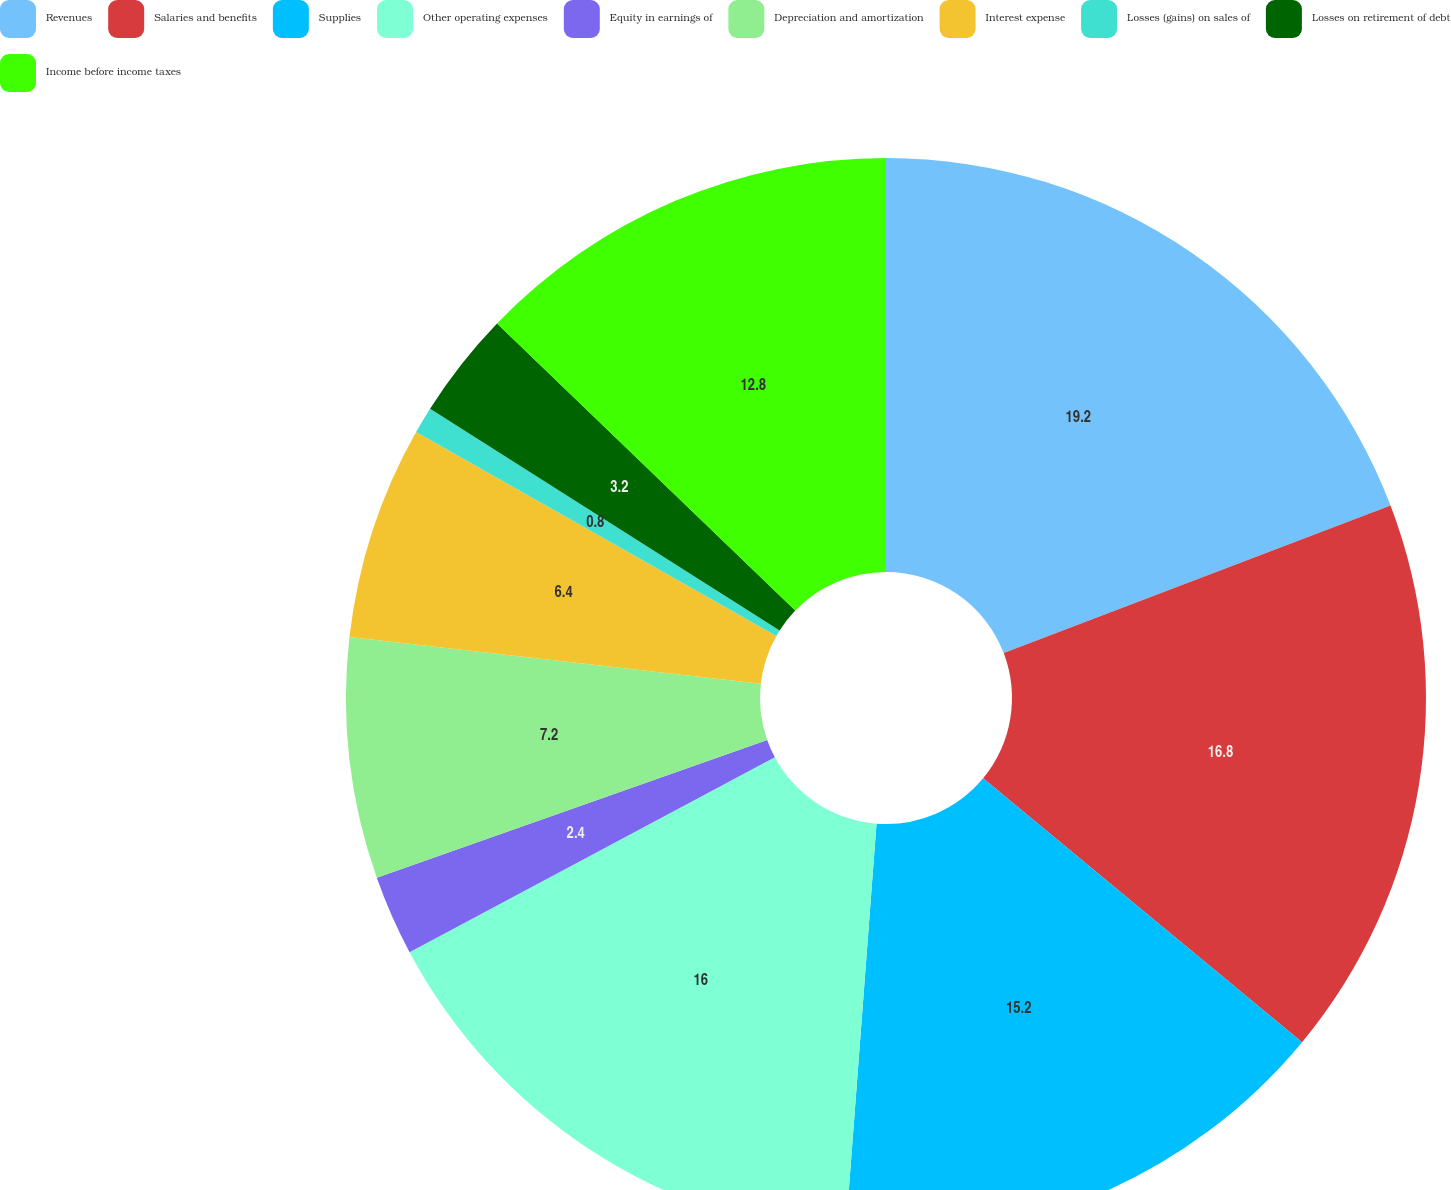Convert chart to OTSL. <chart><loc_0><loc_0><loc_500><loc_500><pie_chart><fcel>Revenues<fcel>Salaries and benefits<fcel>Supplies<fcel>Other operating expenses<fcel>Equity in earnings of<fcel>Depreciation and amortization<fcel>Interest expense<fcel>Losses (gains) on sales of<fcel>Losses on retirement of debt<fcel>Income before income taxes<nl><fcel>19.2%<fcel>16.8%<fcel>15.2%<fcel>16.0%<fcel>2.4%<fcel>7.2%<fcel>6.4%<fcel>0.8%<fcel>3.2%<fcel>12.8%<nl></chart> 